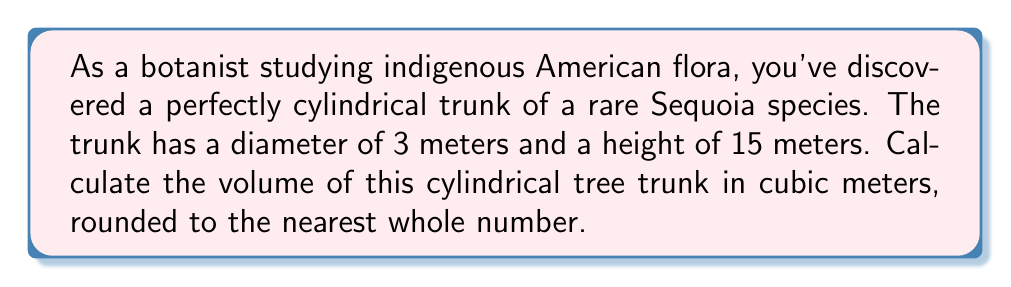Give your solution to this math problem. To calculate the volume of a cylindrical tree trunk, we need to use the formula for the volume of a cylinder:

$$V = \pi r^2 h$$

Where:
$V$ = volume
$r$ = radius of the base
$h$ = height of the cylinder

Steps:
1. Determine the radius:
   The diameter is 3 meters, so the radius is half of that.
   $r = 3 \div 2 = 1.5$ meters

2. Apply the formula:
   $$V = \pi (1.5\text{ m})^2 (15\text{ m})$$

3. Calculate:
   $$V = \pi (2.25\text{ m}^2) (15\text{ m})$$
   $$V = 33.75\pi\text{ m}^3$$

4. Evaluate and round to the nearest whole number:
   $$V \approx 106\text{ m}^3$$
Answer: $106\text{ m}^3$ 